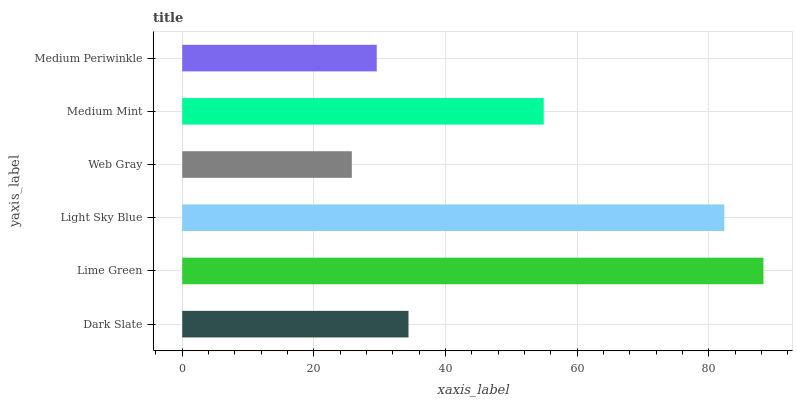Is Web Gray the minimum?
Answer yes or no. Yes. Is Lime Green the maximum?
Answer yes or no. Yes. Is Light Sky Blue the minimum?
Answer yes or no. No. Is Light Sky Blue the maximum?
Answer yes or no. No. Is Lime Green greater than Light Sky Blue?
Answer yes or no. Yes. Is Light Sky Blue less than Lime Green?
Answer yes or no. Yes. Is Light Sky Blue greater than Lime Green?
Answer yes or no. No. Is Lime Green less than Light Sky Blue?
Answer yes or no. No. Is Medium Mint the high median?
Answer yes or no. Yes. Is Dark Slate the low median?
Answer yes or no. Yes. Is Dark Slate the high median?
Answer yes or no. No. Is Lime Green the low median?
Answer yes or no. No. 